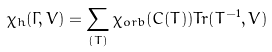Convert formula to latex. <formula><loc_0><loc_0><loc_500><loc_500>\chi _ { h } ( \Gamma , V ) = \sum _ { ( T ) } \chi _ { o r b } ( C ( T ) ) T r ( T ^ { - 1 } , V )</formula> 